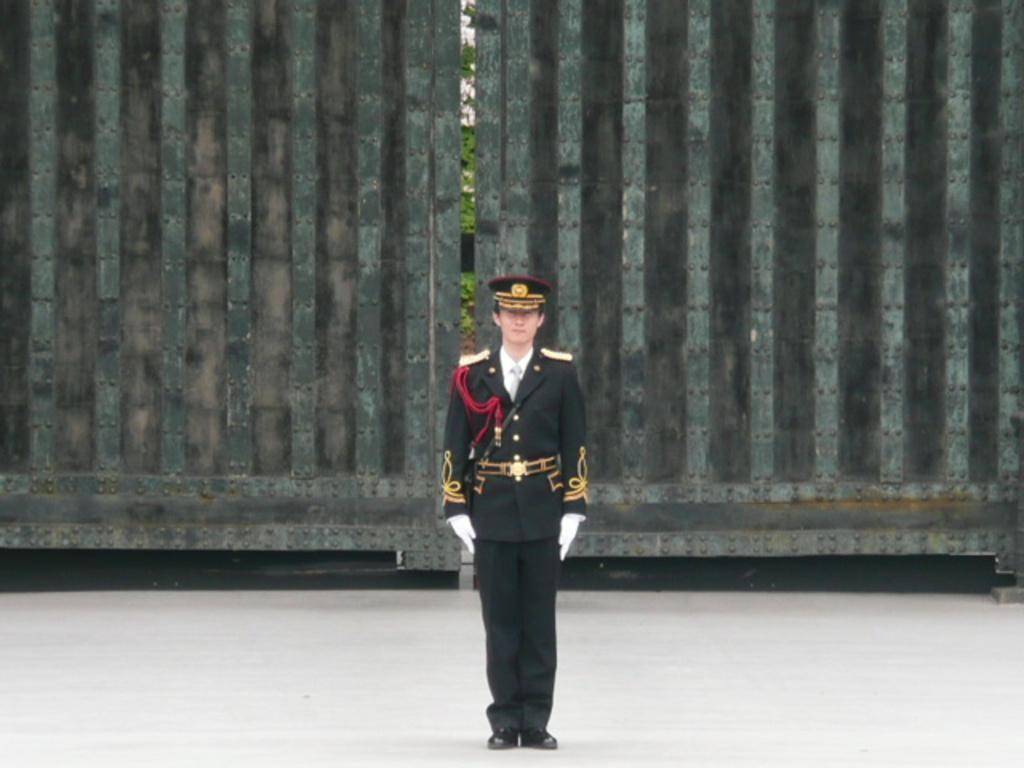Please provide a concise description of this image. In this image I can see a person standing and the person is wearing black and white uniform, background I can see a gate and I can see plants in green color and the sky is in white color. 